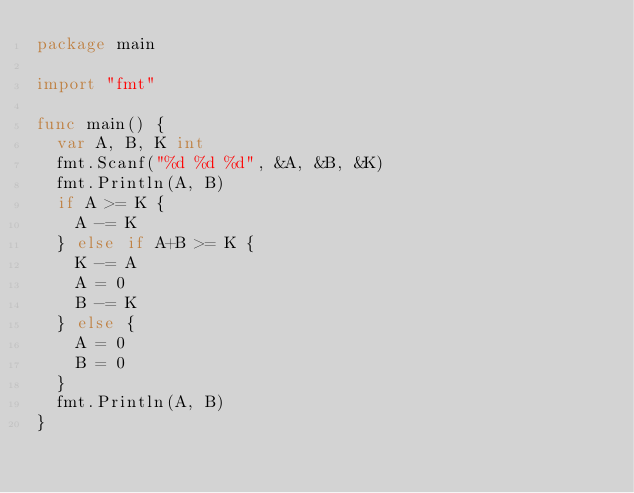<code> <loc_0><loc_0><loc_500><loc_500><_Go_>package main

import "fmt"

func main() {
	var A, B, K int
	fmt.Scanf("%d %d %d", &A, &B, &K)
	fmt.Println(A, B)
	if A >= K {
		A -= K
	} else if A+B >= K {
		K -= A
		A = 0
		B -= K
	} else {
		A = 0
		B = 0
	}
	fmt.Println(A, B)
}
</code> 